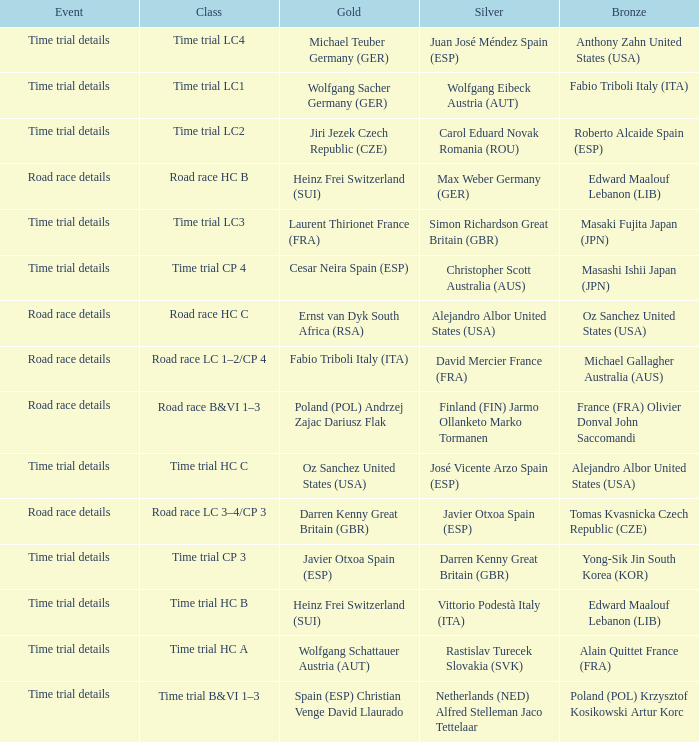What is the event when the class is time trial hc a? Time trial details. 